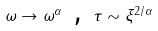Convert formula to latex. <formula><loc_0><loc_0><loc_500><loc_500>\omega \rightarrow \omega ^ { \alpha } \text { , } \tau \sim \xi ^ { 2 / \alpha }</formula> 